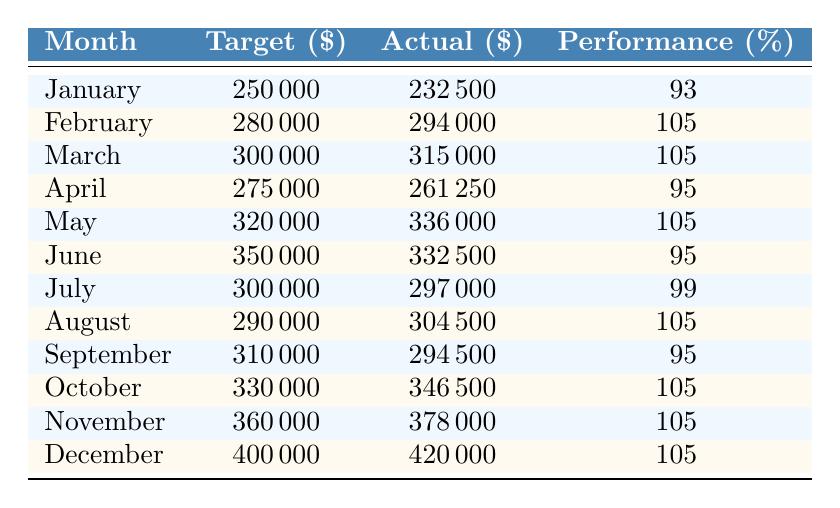What was the target sales for April? The table lists the sales target for each month. For April, the target is specifically stated under the "Target ($)" column.
Answer: 275000 How much did actual sales exceed the target in February? In February, the target was 280000, and actual sales were 294000. The difference is calculated by subtracting the target from the actual: 294000 - 280000 = 14000.
Answer: 14000 What is the average performance percentage over the year? To find the average performance percentage, sum up the performance percentages for all months and then divide by the number of months. The sum is (93 + 105 + 105 + 95 + 105 + 95 + 99 + 105 + 95 + 105 + 105 + 105) = 1178, divided by 12 gives 1178 / 12 = 98.17.
Answer: 98.17 Did the company meet its sales target in March? By checking the actual sales in March (315000) against the target (300000), we see that actual sales exceeded the target. Therefore, the company did meet its sales target in that month.
Answer: Yes Which month had the highest actual sales, and what was that amount? Reviewing the "Actual ($)" column, December shows the highest actual sales at 420000.
Answer: December, 420000 How many months had a performance percentage above 100%? Counting the rows in the "Performance (%)" column, February, March, May, August, October, November, and December had performance percentages above 100. This totals to 7 months.
Answer: 7 Is there any month where actual sales were less than the target? In the months of January (232500) and April (261250), actual sales were below the respective targets of 250000 and 275000. Hence, there were months where actual sales did not meet the targets.
Answer: Yes What is the total sales target for the first half of the year (January to June)? Adding the target sales for January (250000), February (280000), March (300000), April (275000), May (320000), and June (350000) gives a total of: 250000 + 280000 + 300000 + 275000 + 320000 + 350000 = 1,775,000.
Answer: 1775000 In which month did the actual sales come closest to the target? To determine this, we find the month with the smallest absolute difference between the target and actual sales. By examining the table, in July, the actual sales were 297000, which is 3000 below the target of 300000, making it the closest month to the target.
Answer: July 